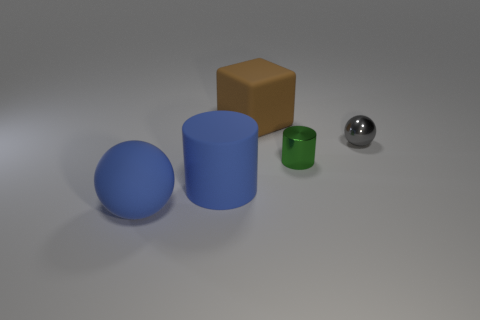Add 2 small purple spheres. How many objects exist? 7 Subtract all blocks. How many objects are left? 4 Subtract all gray balls. How many balls are left? 1 Subtract all red spheres. Subtract all yellow blocks. How many spheres are left? 2 Subtract all cyan blocks. How many green cylinders are left? 1 Subtract all small matte balls. Subtract all big brown matte cubes. How many objects are left? 4 Add 4 big matte objects. How many big matte objects are left? 7 Add 5 blue shiny things. How many blue shiny things exist? 5 Subtract 0 cyan cylinders. How many objects are left? 5 Subtract 1 blocks. How many blocks are left? 0 